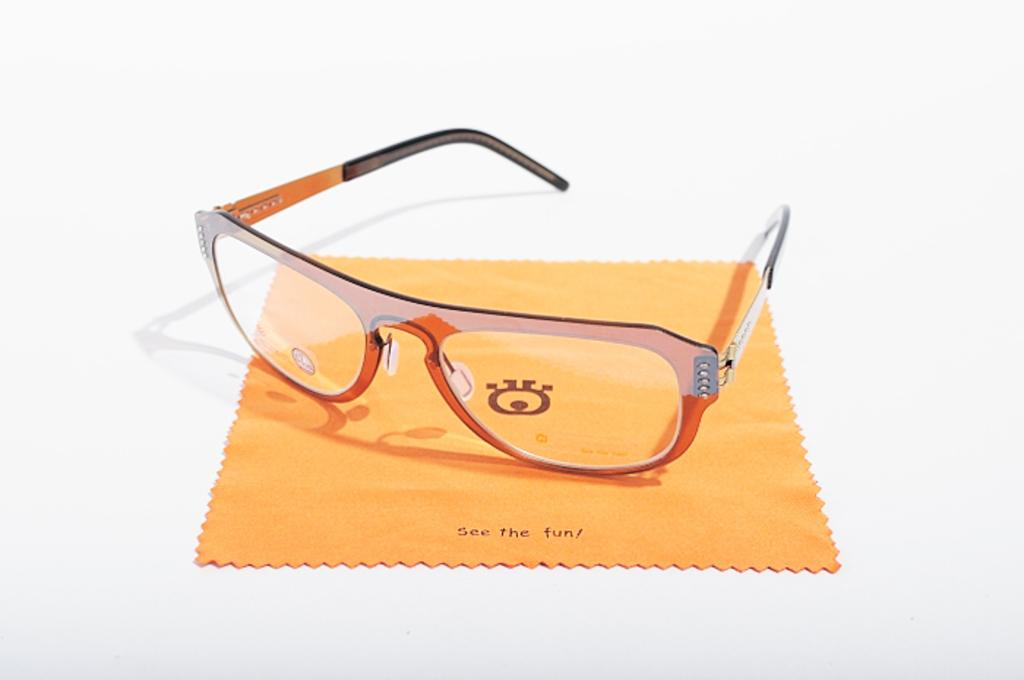What type of eyewear is present in the image? There are spectacles in the image. What other object can be seen in the image? There is a cloth in the image. On what surface are the spectacles and cloth placed? The spectacles and cloth are on a white surface. Where is the sink located in the image? There is no sink present in the image. What country is depicted in the image? The image does not depict any specific country. What type of engine can be seen in the image? There is no engine present in the image. 